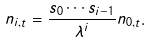<formula> <loc_0><loc_0><loc_500><loc_500>n _ { i , t } = { \frac { s _ { 0 } \cdots s _ { i - 1 } } { \lambda ^ { i } } } n _ { 0 , t } .</formula> 